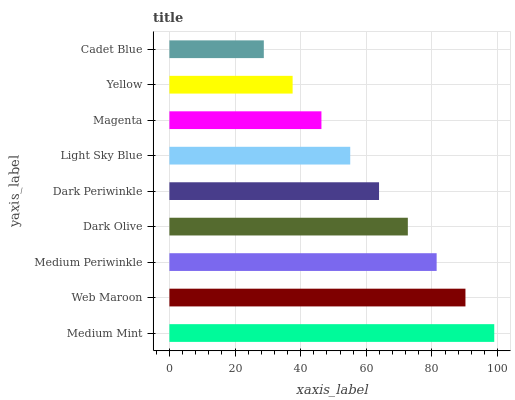Is Cadet Blue the minimum?
Answer yes or no. Yes. Is Medium Mint the maximum?
Answer yes or no. Yes. Is Web Maroon the minimum?
Answer yes or no. No. Is Web Maroon the maximum?
Answer yes or no. No. Is Medium Mint greater than Web Maroon?
Answer yes or no. Yes. Is Web Maroon less than Medium Mint?
Answer yes or no. Yes. Is Web Maroon greater than Medium Mint?
Answer yes or no. No. Is Medium Mint less than Web Maroon?
Answer yes or no. No. Is Dark Periwinkle the high median?
Answer yes or no. Yes. Is Dark Periwinkle the low median?
Answer yes or no. Yes. Is Medium Mint the high median?
Answer yes or no. No. Is Yellow the low median?
Answer yes or no. No. 